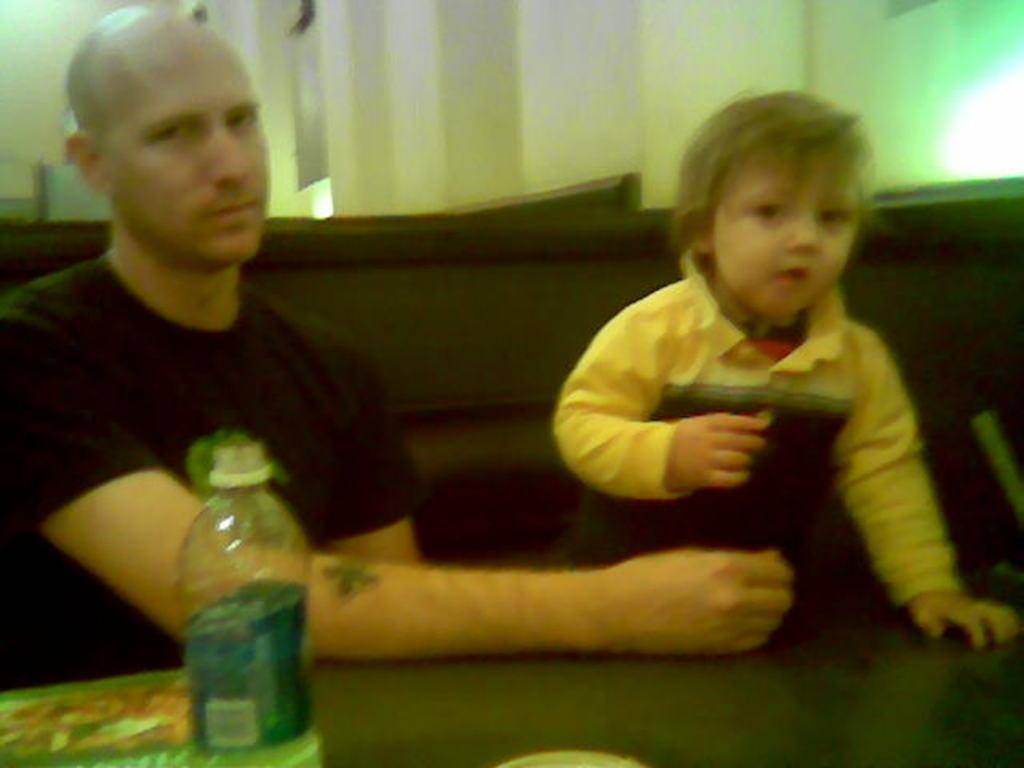Describe this image in one or two sentences. In this image I can see a man and a child. here I can see a water bottle. 